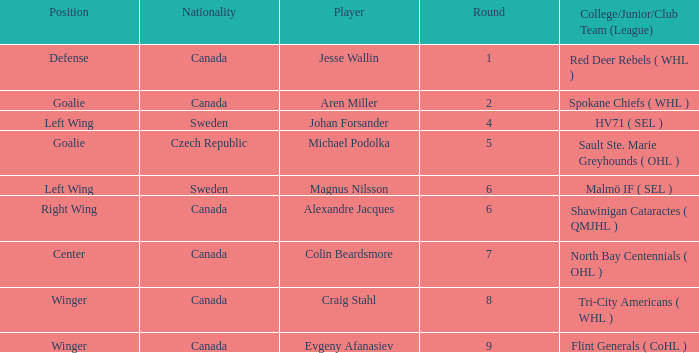What is the School/Junior/Club Group (Class) that has a Nationality of canada, and a Place of goalie? Spokane Chiefs ( WHL ). Can you give me this table as a dict? {'header': ['Position', 'Nationality', 'Player', 'Round', 'College/Junior/Club Team (League)'], 'rows': [['Defense', 'Canada', 'Jesse Wallin', '1', 'Red Deer Rebels ( WHL )'], ['Goalie', 'Canada', 'Aren Miller', '2', 'Spokane Chiefs ( WHL )'], ['Left Wing', 'Sweden', 'Johan Forsander', '4', 'HV71 ( SEL )'], ['Goalie', 'Czech Republic', 'Michael Podolka', '5', 'Sault Ste. Marie Greyhounds ( OHL )'], ['Left Wing', 'Sweden', 'Magnus Nilsson', '6', 'Malmö IF ( SEL )'], ['Right Wing', 'Canada', 'Alexandre Jacques', '6', 'Shawinigan Cataractes ( QMJHL )'], ['Center', 'Canada', 'Colin Beardsmore', '7', 'North Bay Centennials ( OHL )'], ['Winger', 'Canada', 'Craig Stahl', '8', 'Tri-City Americans ( WHL )'], ['Winger', 'Canada', 'Evgeny Afanasiev', '9', 'Flint Generals ( CoHL )']]} 